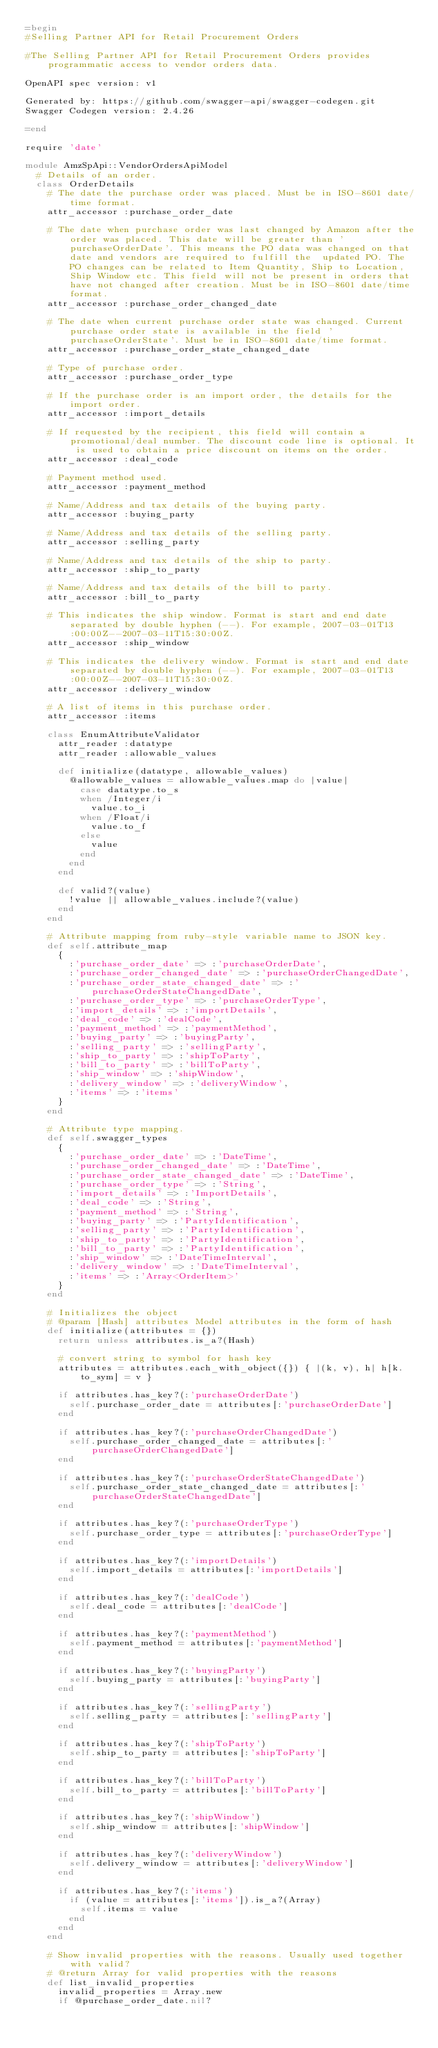<code> <loc_0><loc_0><loc_500><loc_500><_Ruby_>=begin
#Selling Partner API for Retail Procurement Orders

#The Selling Partner API for Retail Procurement Orders provides programmatic access to vendor orders data.

OpenAPI spec version: v1

Generated by: https://github.com/swagger-api/swagger-codegen.git
Swagger Codegen version: 2.4.26

=end

require 'date'

module AmzSpApi::VendorOrdersApiModel
  # Details of an order.
  class OrderDetails
    # The date the purchase order was placed. Must be in ISO-8601 date/time format.
    attr_accessor :purchase_order_date

    # The date when purchase order was last changed by Amazon after the order was placed. This date will be greater than 'purchaseOrderDate'. This means the PO data was changed on that date and vendors are required to fulfill the  updated PO. The PO changes can be related to Item Quantity, Ship to Location, Ship Window etc. This field will not be present in orders that have not changed after creation. Must be in ISO-8601 date/time format.
    attr_accessor :purchase_order_changed_date

    # The date when current purchase order state was changed. Current purchase order state is available in the field 'purchaseOrderState'. Must be in ISO-8601 date/time format.
    attr_accessor :purchase_order_state_changed_date

    # Type of purchase order.
    attr_accessor :purchase_order_type

    # If the purchase order is an import order, the details for the import order.
    attr_accessor :import_details

    # If requested by the recipient, this field will contain a promotional/deal number. The discount code line is optional. It is used to obtain a price discount on items on the order.
    attr_accessor :deal_code

    # Payment method used.
    attr_accessor :payment_method

    # Name/Address and tax details of the buying party.
    attr_accessor :buying_party

    # Name/Address and tax details of the selling party.
    attr_accessor :selling_party

    # Name/Address and tax details of the ship to party.
    attr_accessor :ship_to_party

    # Name/Address and tax details of the bill to party.
    attr_accessor :bill_to_party

    # This indicates the ship window. Format is start and end date separated by double hyphen (--). For example, 2007-03-01T13:00:00Z--2007-03-11T15:30:00Z.
    attr_accessor :ship_window

    # This indicates the delivery window. Format is start and end date separated by double hyphen (--). For example, 2007-03-01T13:00:00Z--2007-03-11T15:30:00Z.
    attr_accessor :delivery_window

    # A list of items in this purchase order.
    attr_accessor :items

    class EnumAttributeValidator
      attr_reader :datatype
      attr_reader :allowable_values

      def initialize(datatype, allowable_values)
        @allowable_values = allowable_values.map do |value|
          case datatype.to_s
          when /Integer/i
            value.to_i
          when /Float/i
            value.to_f
          else
            value
          end
        end
      end

      def valid?(value)
        !value || allowable_values.include?(value)
      end
    end

    # Attribute mapping from ruby-style variable name to JSON key.
    def self.attribute_map
      {
        :'purchase_order_date' => :'purchaseOrderDate',
        :'purchase_order_changed_date' => :'purchaseOrderChangedDate',
        :'purchase_order_state_changed_date' => :'purchaseOrderStateChangedDate',
        :'purchase_order_type' => :'purchaseOrderType',
        :'import_details' => :'importDetails',
        :'deal_code' => :'dealCode',
        :'payment_method' => :'paymentMethod',
        :'buying_party' => :'buyingParty',
        :'selling_party' => :'sellingParty',
        :'ship_to_party' => :'shipToParty',
        :'bill_to_party' => :'billToParty',
        :'ship_window' => :'shipWindow',
        :'delivery_window' => :'deliveryWindow',
        :'items' => :'items'
      }
    end

    # Attribute type mapping.
    def self.swagger_types
      {
        :'purchase_order_date' => :'DateTime',
        :'purchase_order_changed_date' => :'DateTime',
        :'purchase_order_state_changed_date' => :'DateTime',
        :'purchase_order_type' => :'String',
        :'import_details' => :'ImportDetails',
        :'deal_code' => :'String',
        :'payment_method' => :'String',
        :'buying_party' => :'PartyIdentification',
        :'selling_party' => :'PartyIdentification',
        :'ship_to_party' => :'PartyIdentification',
        :'bill_to_party' => :'PartyIdentification',
        :'ship_window' => :'DateTimeInterval',
        :'delivery_window' => :'DateTimeInterval',
        :'items' => :'Array<OrderItem>'
      }
    end

    # Initializes the object
    # @param [Hash] attributes Model attributes in the form of hash
    def initialize(attributes = {})
      return unless attributes.is_a?(Hash)

      # convert string to symbol for hash key
      attributes = attributes.each_with_object({}) { |(k, v), h| h[k.to_sym] = v }

      if attributes.has_key?(:'purchaseOrderDate')
        self.purchase_order_date = attributes[:'purchaseOrderDate']
      end

      if attributes.has_key?(:'purchaseOrderChangedDate')
        self.purchase_order_changed_date = attributes[:'purchaseOrderChangedDate']
      end

      if attributes.has_key?(:'purchaseOrderStateChangedDate')
        self.purchase_order_state_changed_date = attributes[:'purchaseOrderStateChangedDate']
      end

      if attributes.has_key?(:'purchaseOrderType')
        self.purchase_order_type = attributes[:'purchaseOrderType']
      end

      if attributes.has_key?(:'importDetails')
        self.import_details = attributes[:'importDetails']
      end

      if attributes.has_key?(:'dealCode')
        self.deal_code = attributes[:'dealCode']
      end

      if attributes.has_key?(:'paymentMethod')
        self.payment_method = attributes[:'paymentMethod']
      end

      if attributes.has_key?(:'buyingParty')
        self.buying_party = attributes[:'buyingParty']
      end

      if attributes.has_key?(:'sellingParty')
        self.selling_party = attributes[:'sellingParty']
      end

      if attributes.has_key?(:'shipToParty')
        self.ship_to_party = attributes[:'shipToParty']
      end

      if attributes.has_key?(:'billToParty')
        self.bill_to_party = attributes[:'billToParty']
      end

      if attributes.has_key?(:'shipWindow')
        self.ship_window = attributes[:'shipWindow']
      end

      if attributes.has_key?(:'deliveryWindow')
        self.delivery_window = attributes[:'deliveryWindow']
      end

      if attributes.has_key?(:'items')
        if (value = attributes[:'items']).is_a?(Array)
          self.items = value
        end
      end
    end

    # Show invalid properties with the reasons. Usually used together with valid?
    # @return Array for valid properties with the reasons
    def list_invalid_properties
      invalid_properties = Array.new
      if @purchase_order_date.nil?</code> 